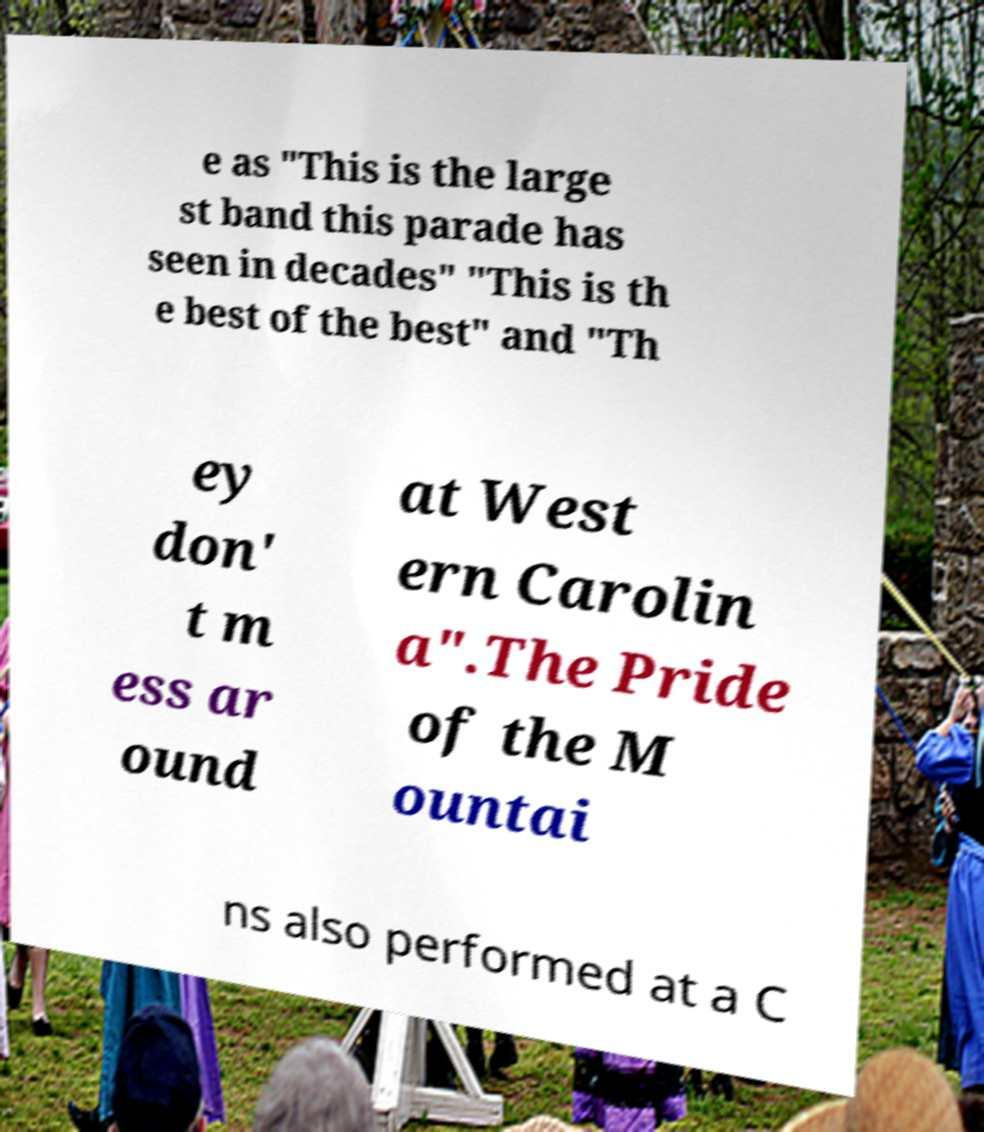Could you assist in decoding the text presented in this image and type it out clearly? e as "This is the large st band this parade has seen in decades" "This is th e best of the best" and "Th ey don' t m ess ar ound at West ern Carolin a".The Pride of the M ountai ns also performed at a C 